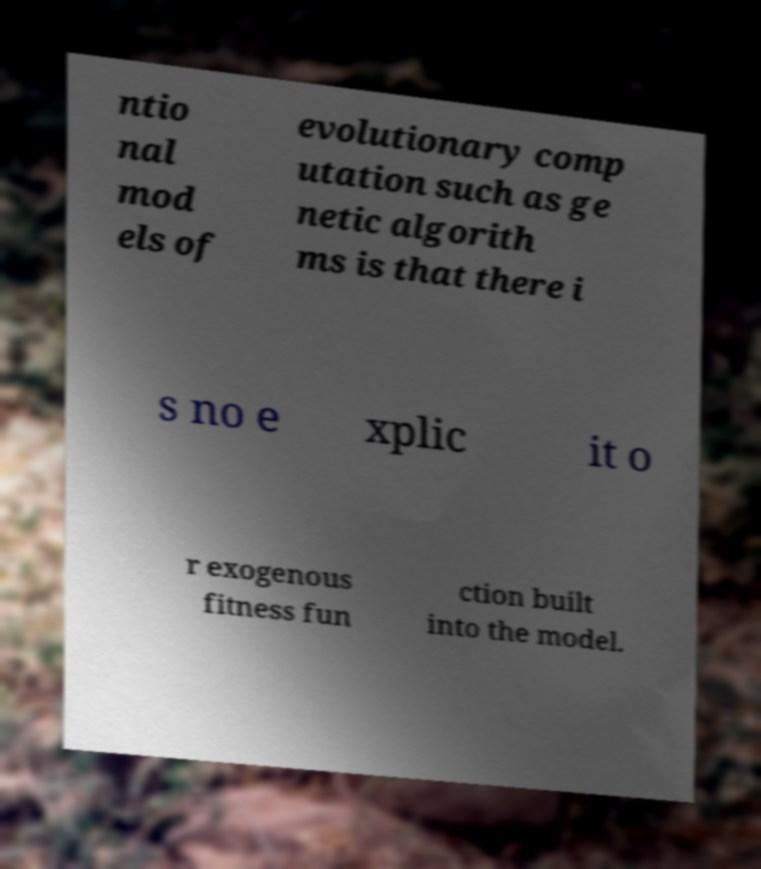Please identify and transcribe the text found in this image. ntio nal mod els of evolutionary comp utation such as ge netic algorith ms is that there i s no e xplic it o r exogenous fitness fun ction built into the model. 